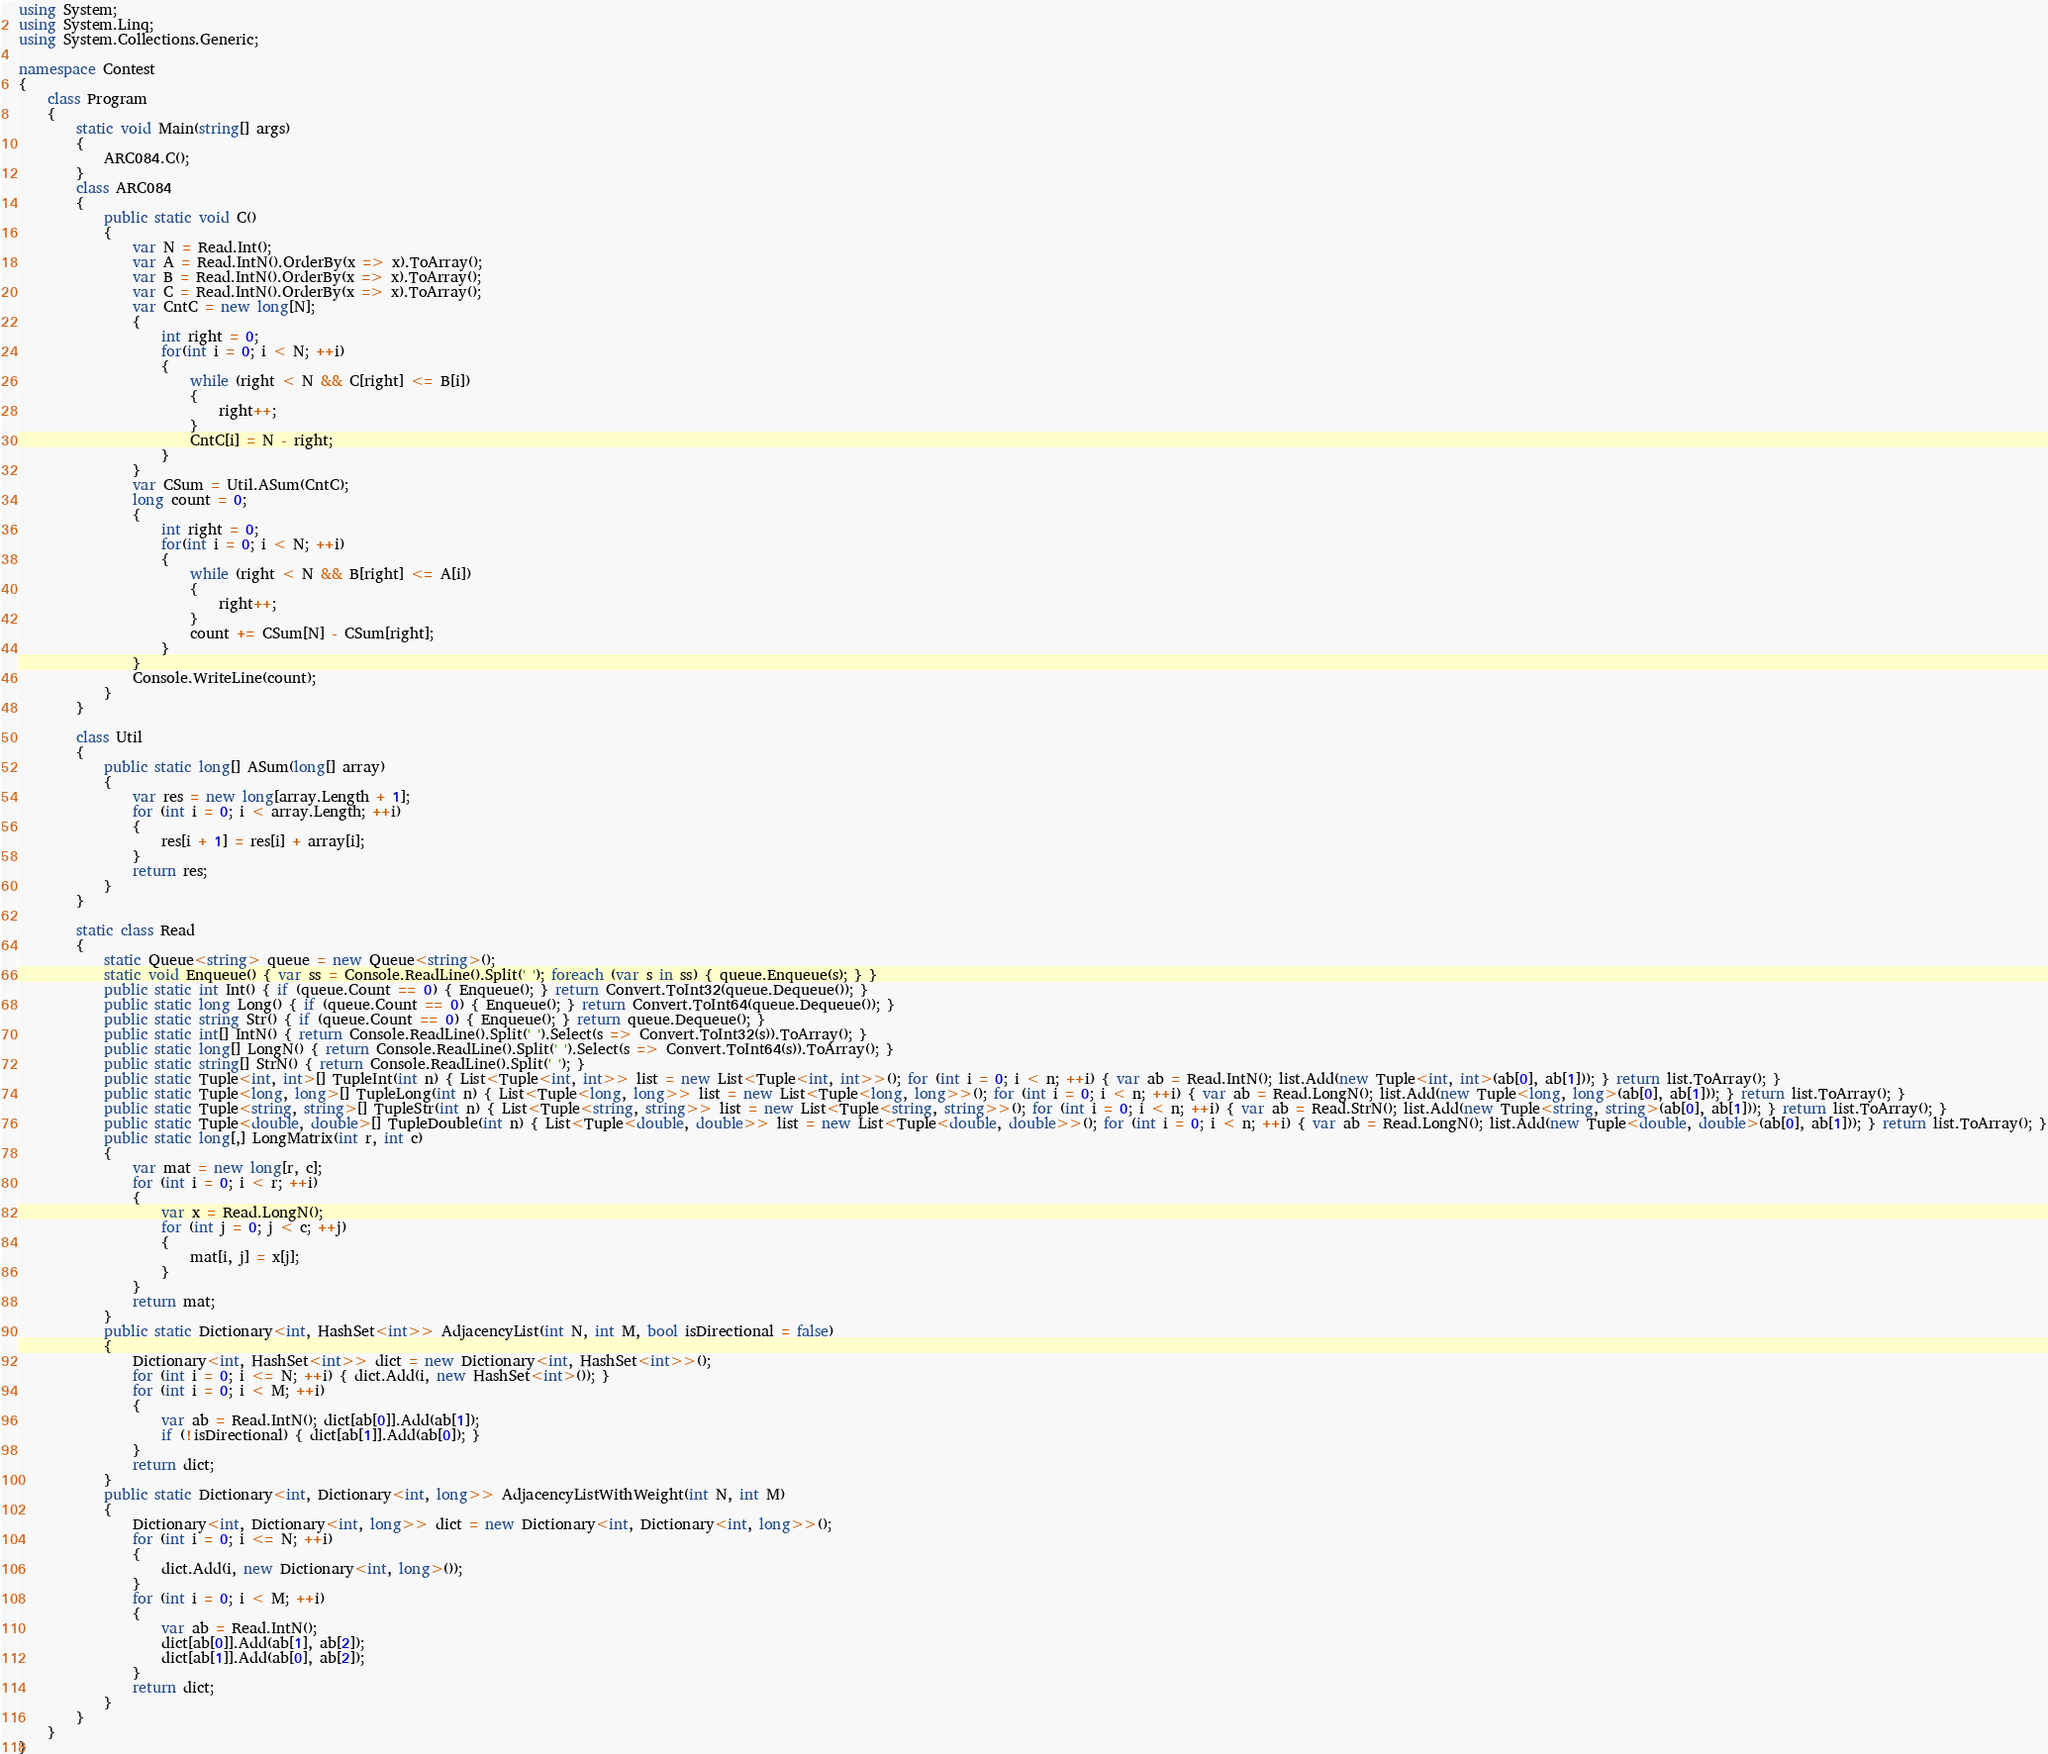Convert code to text. <code><loc_0><loc_0><loc_500><loc_500><_C#_>using System;
using System.Linq;
using System.Collections.Generic;

namespace Contest
{
    class Program
    {
        static void Main(string[] args)
        {
            ARC084.C();
        }
        class ARC084
        {
            public static void C()
            {
                var N = Read.Int();
                var A = Read.IntN().OrderBy(x => x).ToArray();
                var B = Read.IntN().OrderBy(x => x).ToArray();
                var C = Read.IntN().OrderBy(x => x).ToArray();
                var CntC = new long[N];
                {
                    int right = 0;
                    for(int i = 0; i < N; ++i)
                    {
                        while (right < N && C[right] <= B[i])
                        {
                            right++;
                        }
                        CntC[i] = N - right;
                    }
                }
                var CSum = Util.ASum(CntC);
                long count = 0;
                {
                    int right = 0;
                    for(int i = 0; i < N; ++i)
                    {
                        while (right < N && B[right] <= A[i])
                        {
                            right++;
                        }
                        count += CSum[N] - CSum[right];
                    }
                }
                Console.WriteLine(count);
            }
        }

        class Util
        {
            public static long[] ASum(long[] array)
            {
                var res = new long[array.Length + 1];
                for (int i = 0; i < array.Length; ++i)
                {
                    res[i + 1] = res[i] + array[i];
                }
                return res;
            }
        }

        static class Read
        {
            static Queue<string> queue = new Queue<string>();
            static void Enqueue() { var ss = Console.ReadLine().Split(' '); foreach (var s in ss) { queue.Enqueue(s); } }
            public static int Int() { if (queue.Count == 0) { Enqueue(); } return Convert.ToInt32(queue.Dequeue()); }
            public static long Long() { if (queue.Count == 0) { Enqueue(); } return Convert.ToInt64(queue.Dequeue()); }
            public static string Str() { if (queue.Count == 0) { Enqueue(); } return queue.Dequeue(); }
            public static int[] IntN() { return Console.ReadLine().Split(' ').Select(s => Convert.ToInt32(s)).ToArray(); }
            public static long[] LongN() { return Console.ReadLine().Split(' ').Select(s => Convert.ToInt64(s)).ToArray(); }
            public static string[] StrN() { return Console.ReadLine().Split(' '); }
            public static Tuple<int, int>[] TupleInt(int n) { List<Tuple<int, int>> list = new List<Tuple<int, int>>(); for (int i = 0; i < n; ++i) { var ab = Read.IntN(); list.Add(new Tuple<int, int>(ab[0], ab[1])); } return list.ToArray(); }
            public static Tuple<long, long>[] TupleLong(int n) { List<Tuple<long, long>> list = new List<Tuple<long, long>>(); for (int i = 0; i < n; ++i) { var ab = Read.LongN(); list.Add(new Tuple<long, long>(ab[0], ab[1])); } return list.ToArray(); }
            public static Tuple<string, string>[] TupleStr(int n) { List<Tuple<string, string>> list = new List<Tuple<string, string>>(); for (int i = 0; i < n; ++i) { var ab = Read.StrN(); list.Add(new Tuple<string, string>(ab[0], ab[1])); } return list.ToArray(); }
            public static Tuple<double, double>[] TupleDouble(int n) { List<Tuple<double, double>> list = new List<Tuple<double, double>>(); for (int i = 0; i < n; ++i) { var ab = Read.LongN(); list.Add(new Tuple<double, double>(ab[0], ab[1])); } return list.ToArray(); }
            public static long[,] LongMatrix(int r, int c)
            {
                var mat = new long[r, c];
                for (int i = 0; i < r; ++i)
                {
                    var x = Read.LongN();
                    for (int j = 0; j < c; ++j)
                    {
                        mat[i, j] = x[j];
                    }
                }
                return mat;
            }
            public static Dictionary<int, HashSet<int>> AdjacencyList(int N, int M, bool isDirectional = false)
            {
                Dictionary<int, HashSet<int>> dict = new Dictionary<int, HashSet<int>>();
                for (int i = 0; i <= N; ++i) { dict.Add(i, new HashSet<int>()); }
                for (int i = 0; i < M; ++i)
                {
                    var ab = Read.IntN(); dict[ab[0]].Add(ab[1]);
                    if (!isDirectional) { dict[ab[1]].Add(ab[0]); }
                }
                return dict;
            }
            public static Dictionary<int, Dictionary<int, long>> AdjacencyListWithWeight(int N, int M)
            {
                Dictionary<int, Dictionary<int, long>> dict = new Dictionary<int, Dictionary<int, long>>();
                for (int i = 0; i <= N; ++i)
                {
                    dict.Add(i, new Dictionary<int, long>());
                }
                for (int i = 0; i < M; ++i)
                {
                    var ab = Read.IntN();
                    dict[ab[0]].Add(ab[1], ab[2]);
                    dict[ab[1]].Add(ab[0], ab[2]);
                }
                return dict;
            }
        }
    }
}
</code> 